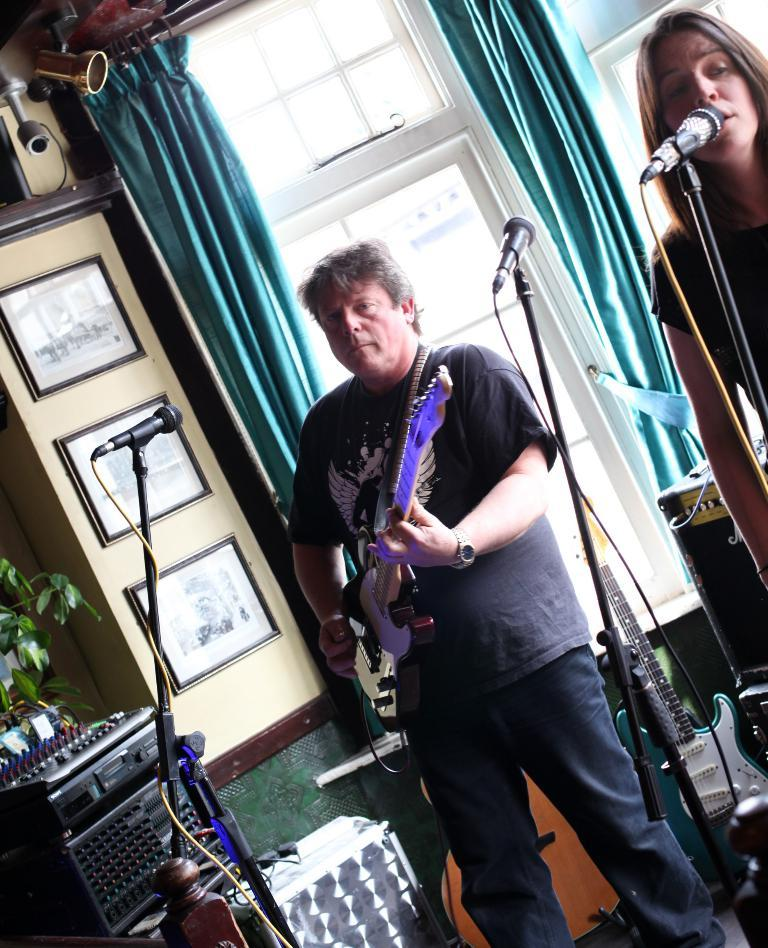What is the woman in the image doing? The woman is singing in the image. What is the woman holding while singing? The woman is holding a microphone. What is the person in the image doing? The person is playing a guitar in the image. What is the person playing the guitar holding? The person is also holding a microphone. What can be seen in the left corner of the image? There is an amplifier in the left corner of the image. Can you see a cup of coffee on the table in the image? There is no table or cup of coffee present in the image. What time of day is it in the image? The time of day is not mentioned or depicted in the image. 